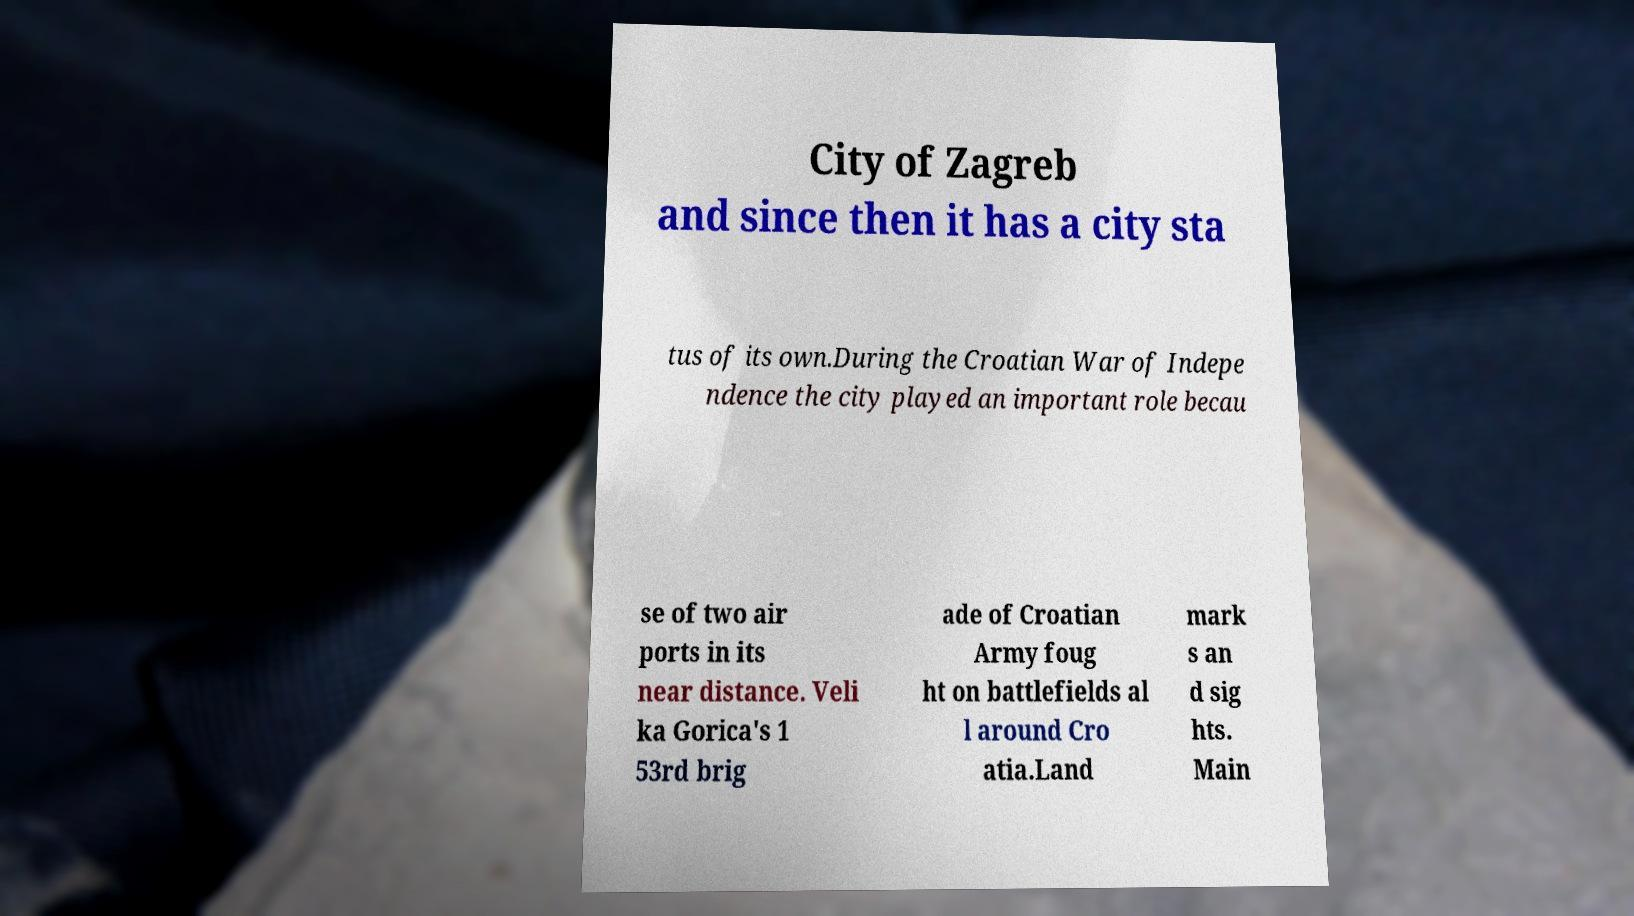Could you assist in decoding the text presented in this image and type it out clearly? City of Zagreb and since then it has a city sta tus of its own.During the Croatian War of Indepe ndence the city played an important role becau se of two air ports in its near distance. Veli ka Gorica's 1 53rd brig ade of Croatian Army foug ht on battlefields al l around Cro atia.Land mark s an d sig hts. Main 